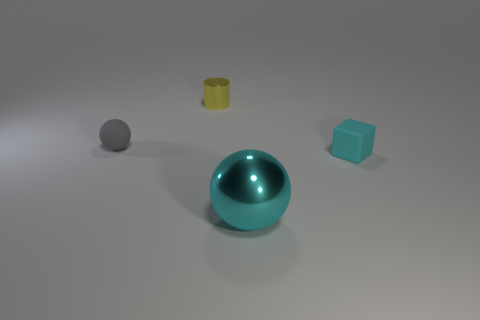Does the small gray object that is in front of the yellow metallic cylinder have the same material as the small cylinder?
Provide a succinct answer. No. Is there anything else that is the same size as the gray sphere?
Offer a very short reply. Yes. Is the number of gray matte spheres on the left side of the small matte block less than the number of tiny things left of the cyan ball?
Make the answer very short. Yes. Is there anything else that has the same shape as the big thing?
Keep it short and to the point. Yes. There is a large thing that is the same color as the small rubber block; what is its material?
Your answer should be compact. Metal. What number of big things are in front of the object behind the small matte thing that is to the left of the small cylinder?
Provide a succinct answer. 1. There is a gray matte sphere; what number of gray rubber balls are on the left side of it?
Make the answer very short. 0. What number of big balls have the same material as the yellow cylinder?
Provide a succinct answer. 1. There is a tiny block that is made of the same material as the small gray thing; what is its color?
Provide a short and direct response. Cyan. There is a cyan object that is right of the metallic object in front of the matte thing that is to the right of the yellow metallic cylinder; what is it made of?
Offer a very short reply. Rubber. 